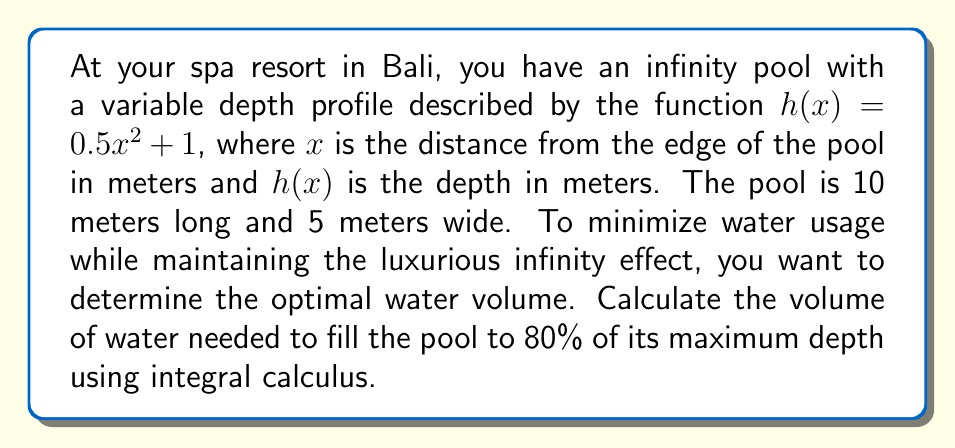Help me with this question. Let's approach this step-by-step:

1) The depth function is given by $h(x) = 0.5x^2 + 1$

2) The pool is 10 meters long, so the maximum depth occurs at $x = 10$:
   $h_{max} = 0.5(10)^2 + 1 = 51$ meters

3) We need to fill 80% of this depth:
   $0.8 * 51 = 40.8$ meters

4) To find the point where the depth is 40.8 meters, solve:
   $0.5x^2 + 1 = 40.8$
   $0.5x^2 = 39.8$
   $x^2 = 79.6$
   $x = \sqrt{79.6} \approx 8.92$ meters

5) The volume can be calculated using the integral:
   $V = 5 \int_0^{8.92} (0.5x^2 + 1) dx$

6) Solving the integral:
   $V = 5 [\frac{1}{6}x^3 + x]_0^{8.92}$
   $V = 5 [(\frac{1}{6}(8.92)^3 + 8.92) - (0 + 0)]$
   $V = 5 [236.09 + 8.92]$
   $V = 5 * 245.01$
   $V = 1225.05$ cubic meters

Therefore, the volume of water needed is approximately 1225.05 cubic meters.
Answer: 1225.05 m³ 